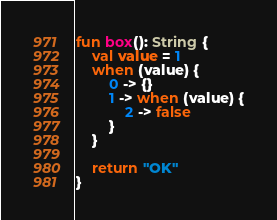Convert code to text. <code><loc_0><loc_0><loc_500><loc_500><_Kotlin_>fun box(): String {
    val value = 1
    when (value) {
        0 -> {}
        1 -> when (value) {
            2 -> false
        }
    }

    return "OK"
}</code> 